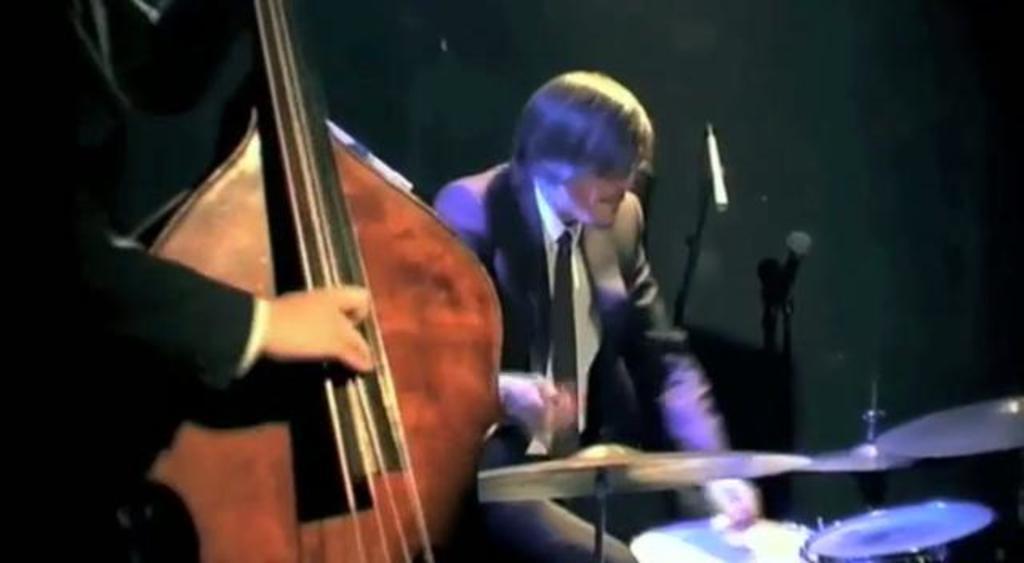Can you describe this image briefly? In this image we can see there are people. There are musical instruments and a microphone. 